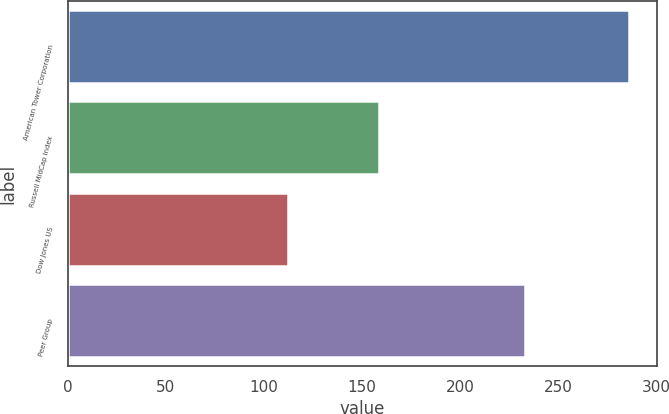Convert chart. <chart><loc_0><loc_0><loc_500><loc_500><bar_chart><fcel>American Tower Corporation<fcel>Russell MidCap Index<fcel>Dow Jones US<fcel>Peer Group<nl><fcel>286.17<fcel>158.98<fcel>112.39<fcel>233.25<nl></chart> 